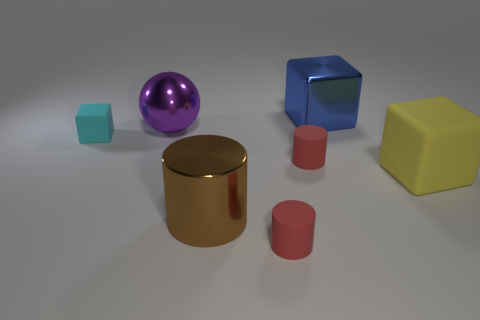Subtract all brown cubes. How many red cylinders are left? 2 Subtract all large shiny cylinders. How many cylinders are left? 2 Add 3 tiny matte things. How many objects exist? 10 Subtract all green cylinders. Subtract all purple cubes. How many cylinders are left? 3 Subtract all cylinders. How many objects are left? 4 Subtract 1 blue blocks. How many objects are left? 6 Subtract all large purple balls. Subtract all big purple objects. How many objects are left? 5 Add 5 large brown metallic objects. How many large brown metallic objects are left? 6 Add 1 large red metallic objects. How many large red metallic objects exist? 1 